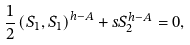<formula> <loc_0><loc_0><loc_500><loc_500>\frac { 1 } { 2 } \left ( S _ { 1 } , S _ { 1 } \right ) ^ { h - A } + s S _ { 2 } ^ { h - A } = 0 ,</formula> 